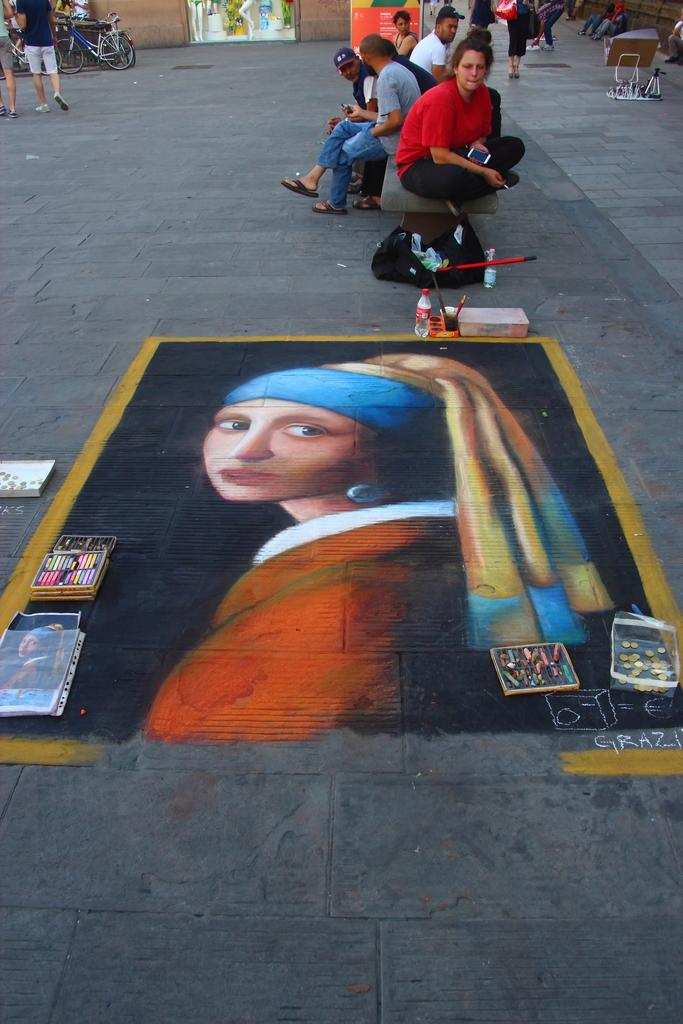How many people are in the image? There are few persons in the image. What is on the road in the image? There is a painting on the road. What objects can be seen in the image besides the painting? There are boxes, bottles, a bag, a bicycle, and boards in the image. What type of structure is visible in the image? There is a wall in the image. What type of food is being prepared by the grandmother in the image? There is no grandmother or food preparation visible in the image. What type of tank is present in the image? There is no tank present in the image. 